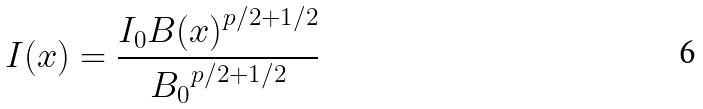Convert formula to latex. <formula><loc_0><loc_0><loc_500><loc_500>I ( x ) = { \frac { I _ { 0 } { B ( x ) } ^ { p / 2 + 1 / 2 } } { { B _ { 0 } } ^ { p / 2 + 1 / 2 } } }</formula> 